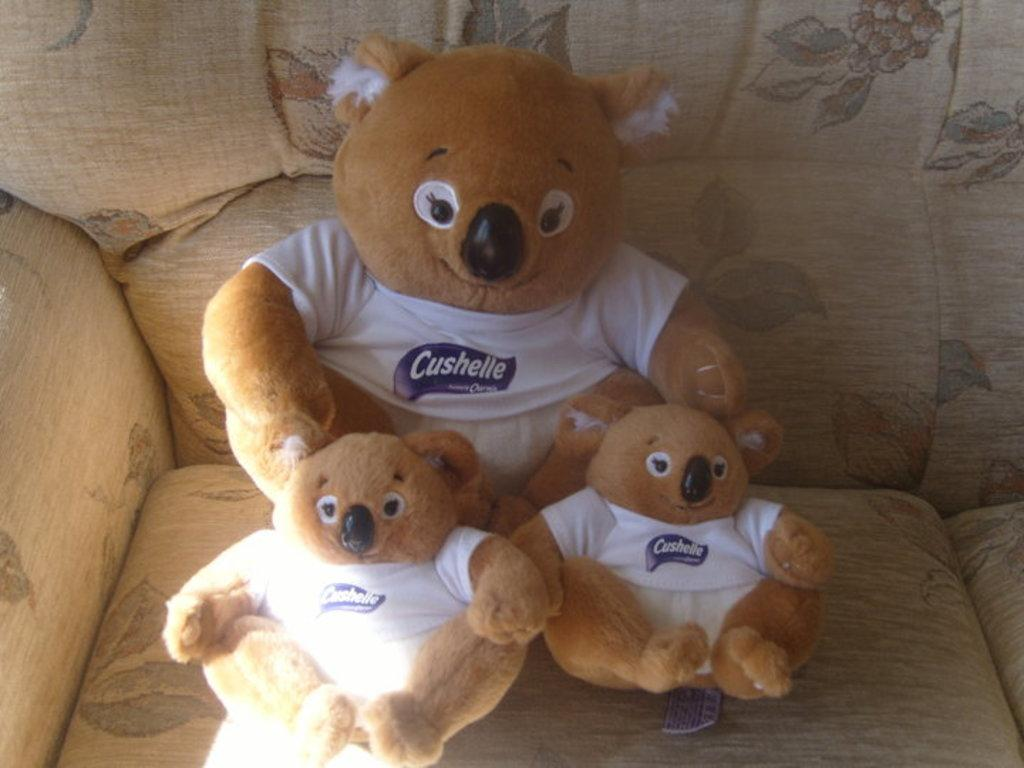What type of stuffed animals are in the image? There are teddy bears in the image. Where are the teddy bears located? The teddy bears are on a sofa. What type of map can be seen on the teddy bears in the image? There is no map present on the teddy bears in the image. What type of game are the teddy bears playing in the image? There is no game being played by the teddy bears in the image. 